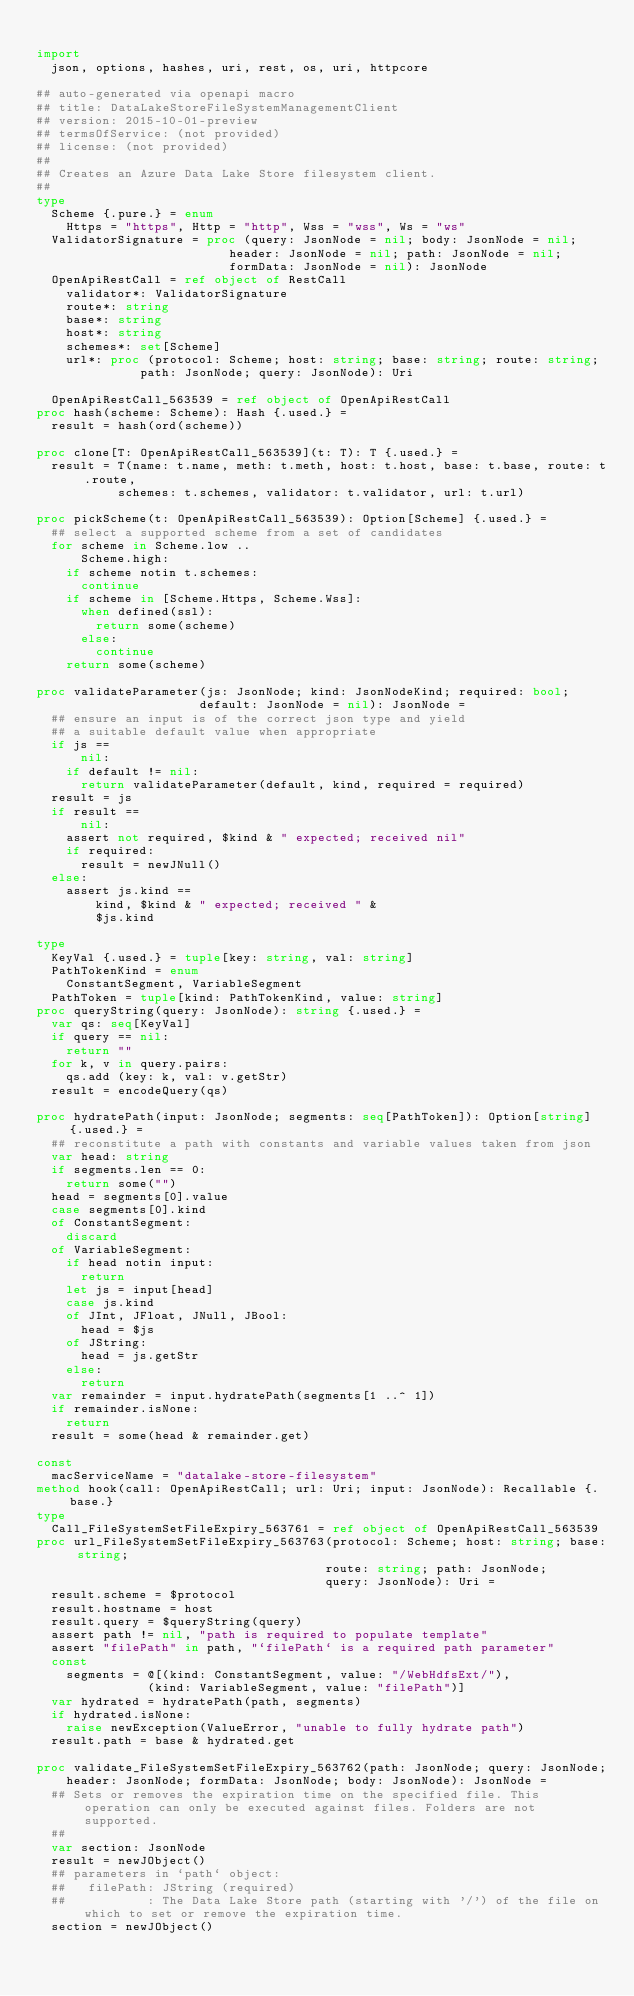<code> <loc_0><loc_0><loc_500><loc_500><_Nim_>
import
  json, options, hashes, uri, rest, os, uri, httpcore

## auto-generated via openapi macro
## title: DataLakeStoreFileSystemManagementClient
## version: 2015-10-01-preview
## termsOfService: (not provided)
## license: (not provided)
## 
## Creates an Azure Data Lake Store filesystem client.
## 
type
  Scheme {.pure.} = enum
    Https = "https", Http = "http", Wss = "wss", Ws = "ws"
  ValidatorSignature = proc (query: JsonNode = nil; body: JsonNode = nil;
                          header: JsonNode = nil; path: JsonNode = nil;
                          formData: JsonNode = nil): JsonNode
  OpenApiRestCall = ref object of RestCall
    validator*: ValidatorSignature
    route*: string
    base*: string
    host*: string
    schemes*: set[Scheme]
    url*: proc (protocol: Scheme; host: string; base: string; route: string;
              path: JsonNode; query: JsonNode): Uri

  OpenApiRestCall_563539 = ref object of OpenApiRestCall
proc hash(scheme: Scheme): Hash {.used.} =
  result = hash(ord(scheme))

proc clone[T: OpenApiRestCall_563539](t: T): T {.used.} =
  result = T(name: t.name, meth: t.meth, host: t.host, base: t.base, route: t.route,
           schemes: t.schemes, validator: t.validator, url: t.url)

proc pickScheme(t: OpenApiRestCall_563539): Option[Scheme] {.used.} =
  ## select a supported scheme from a set of candidates
  for scheme in Scheme.low ..
      Scheme.high:
    if scheme notin t.schemes:
      continue
    if scheme in [Scheme.Https, Scheme.Wss]:
      when defined(ssl):
        return some(scheme)
      else:
        continue
    return some(scheme)

proc validateParameter(js: JsonNode; kind: JsonNodeKind; required: bool;
                      default: JsonNode = nil): JsonNode =
  ## ensure an input is of the correct json type and yield
  ## a suitable default value when appropriate
  if js ==
      nil:
    if default != nil:
      return validateParameter(default, kind, required = required)
  result = js
  if result ==
      nil:
    assert not required, $kind & " expected; received nil"
    if required:
      result = newJNull()
  else:
    assert js.kind ==
        kind, $kind & " expected; received " &
        $js.kind

type
  KeyVal {.used.} = tuple[key: string, val: string]
  PathTokenKind = enum
    ConstantSegment, VariableSegment
  PathToken = tuple[kind: PathTokenKind, value: string]
proc queryString(query: JsonNode): string {.used.} =
  var qs: seq[KeyVal]
  if query == nil:
    return ""
  for k, v in query.pairs:
    qs.add (key: k, val: v.getStr)
  result = encodeQuery(qs)

proc hydratePath(input: JsonNode; segments: seq[PathToken]): Option[string] {.used.} =
  ## reconstitute a path with constants and variable values taken from json
  var head: string
  if segments.len == 0:
    return some("")
  head = segments[0].value
  case segments[0].kind
  of ConstantSegment:
    discard
  of VariableSegment:
    if head notin input:
      return
    let js = input[head]
    case js.kind
    of JInt, JFloat, JNull, JBool:
      head = $js
    of JString:
      head = js.getStr
    else:
      return
  var remainder = input.hydratePath(segments[1 ..^ 1])
  if remainder.isNone:
    return
  result = some(head & remainder.get)

const
  macServiceName = "datalake-store-filesystem"
method hook(call: OpenApiRestCall; url: Uri; input: JsonNode): Recallable {.base.}
type
  Call_FileSystemSetFileExpiry_563761 = ref object of OpenApiRestCall_563539
proc url_FileSystemSetFileExpiry_563763(protocol: Scheme; host: string; base: string;
                                       route: string; path: JsonNode;
                                       query: JsonNode): Uri =
  result.scheme = $protocol
  result.hostname = host
  result.query = $queryString(query)
  assert path != nil, "path is required to populate template"
  assert "filePath" in path, "`filePath` is a required path parameter"
  const
    segments = @[(kind: ConstantSegment, value: "/WebHdfsExt/"),
               (kind: VariableSegment, value: "filePath")]
  var hydrated = hydratePath(path, segments)
  if hydrated.isNone:
    raise newException(ValueError, "unable to fully hydrate path")
  result.path = base & hydrated.get

proc validate_FileSystemSetFileExpiry_563762(path: JsonNode; query: JsonNode;
    header: JsonNode; formData: JsonNode; body: JsonNode): JsonNode =
  ## Sets or removes the expiration time on the specified file. This operation can only be executed against files. Folders are not supported.
  ## 
  var section: JsonNode
  result = newJObject()
  ## parameters in `path` object:
  ##   filePath: JString (required)
  ##           : The Data Lake Store path (starting with '/') of the file on which to set or remove the expiration time.
  section = newJObject()</code> 